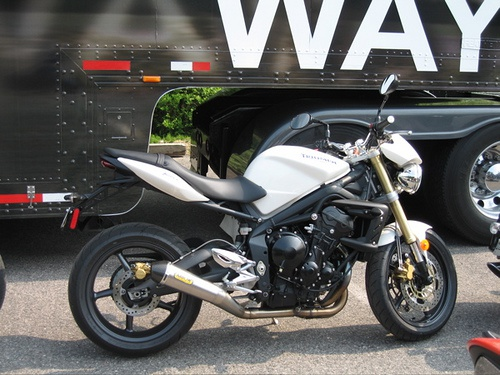Describe the objects in this image and their specific colors. I can see truck in black, gray, and white tones and motorcycle in black, gray, white, and darkgray tones in this image. 